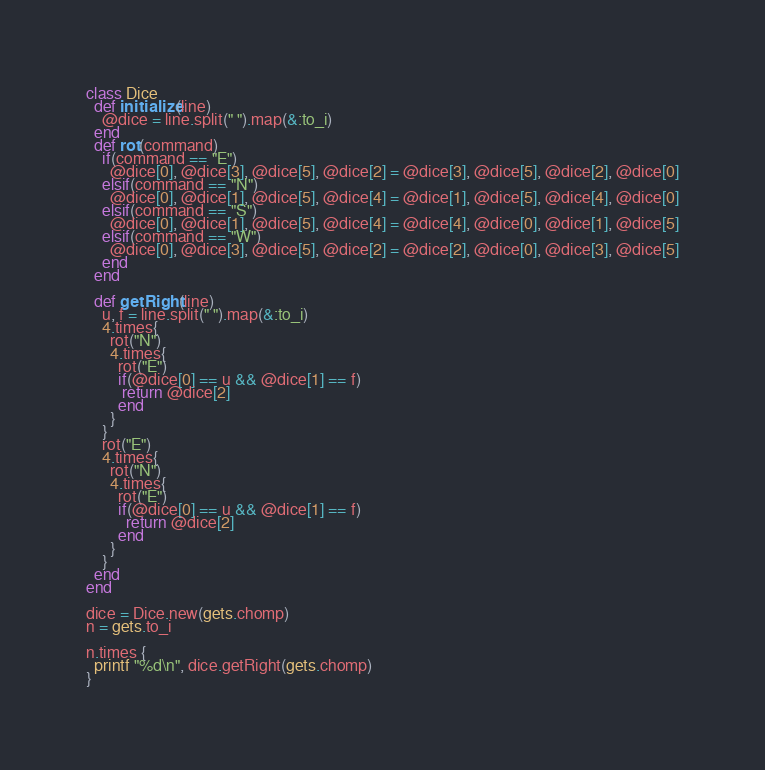Convert code to text. <code><loc_0><loc_0><loc_500><loc_500><_Ruby_>class Dice
  def initialize(line)
    @dice = line.split(" ").map(&:to_i)
  end
  def rot(command)
    if(command == "E") 
      @dice[0], @dice[3], @dice[5], @dice[2] = @dice[3], @dice[5], @dice[2], @dice[0]
    elsif(command == "N") 
      @dice[0], @dice[1], @dice[5], @dice[4] = @dice[1], @dice[5], @dice[4], @dice[0]
    elsif(command == "S") 
      @dice[0], @dice[1], @dice[5], @dice[4] = @dice[4], @dice[0], @dice[1], @dice[5]
    elsif(command == "W") 
      @dice[0], @dice[3], @dice[5], @dice[2] = @dice[2], @dice[0], @dice[3], @dice[5]
    end
  end

  def getRight(line)
    u, f = line.split(" ").map(&:to_i)
    4.times{
      rot("N")
      4.times{
        rot("E")
        if(@dice[0] == u && @dice[1] == f) 
         return @dice[2]
        end
      }
    }
    rot("E")
    4.times{
      rot("N")
      4.times{
        rot("E")
        if(@dice[0] == u && @dice[1] == f) 
          return @dice[2]
        end
      }
    }
  end
end
 
dice = Dice.new(gets.chomp)
n = gets.to_i

n.times {
  printf "%d\n", dice.getRight(gets.chomp)
}
</code> 